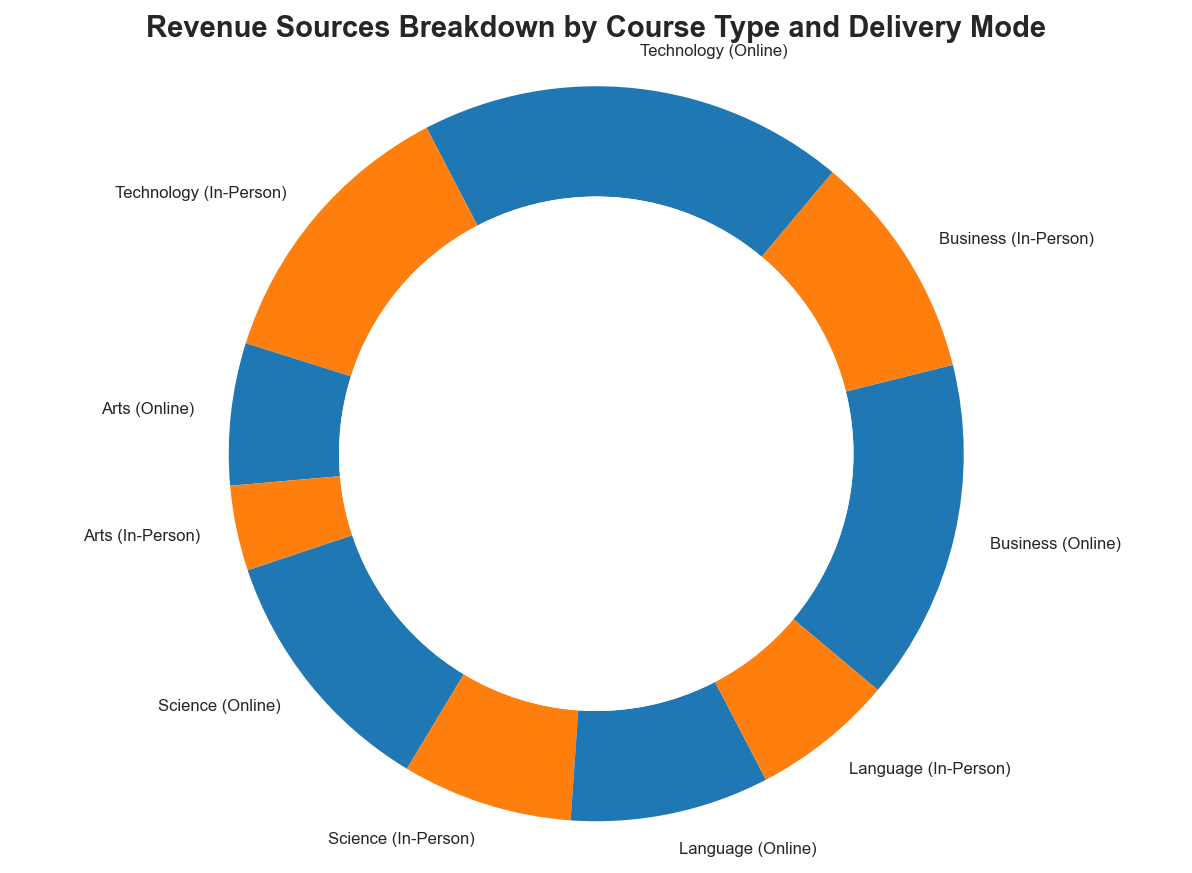What is the total revenue generated from Business courses? Business courses can be found both in Online and In-Person delivery modes in the ring chart. Adding their revenues gives us $120,000 (Online) + $80,000 (In-Person) = $200,000.
Answer: $200,000 Which course type generates the most revenue in total? By examining the ring chart, we see that the Technology course section seems largest. Summing Technology Online and Technology In-Person revenues gives $150,000 + $100,000 = $250,000, which is the highest amount compared to other course types.
Answer: Technology Which delivery mode generates the highest revenue across all course types? We need to compare the total revenues for Online and In-Person deliveries. Summing all Online revenues gives $120,000 + $150,000 + $50,000 + $90,000 + $70,000 = $480,000. Summing In-Person revenues gives $80,000 + $100,000 + $30,000 + $60,000 + $50,000 = $320,000. Online delivery generates a higher total revenue.
Answer: Online What is the difference in revenue between Arts (Online) and Science (Online)? The ring chart shows the revenues for Arts (Online) as $50,000 and Science (Online) as $90,000. The difference is $90,000 - $50,000 = $40,000.
Answer: $40,000 What percentage of the total revenue comes from Language courses (both Online and In-Person)? First, calculate the total revenue from all courses: $480,000 + $320,000 = $800,000. The revenue from Language courses is $70,000 (Online) + $50,000 (In-Person) = $120,000. The percentage is ($120,000 / $800,000) * 100 = 15%.
Answer: 15% Does Technology (In-Person) generate more revenue than Science (Online)? The ring chart shows that Technology (In-Person) generates $100,000 and Science (Online) generates $90,000. Since $100,000 is greater than $90,000, Technology (In-Person) generates more revenue.
Answer: Yes What is the least revenue-generating course type for Online delivery mode? From the ring chart, Arts (Online) has the least revenue among the online modes with $50,000.
Answer: Arts Which has higher revenue: Business (In-Person) or Language (In-Person)? From the ring chart, Business (In-Person) revenue is $80,000 while Language (In-Person) revenue is $50,000. So, Business (In-Person) has higher revenue.
Answer: Business 